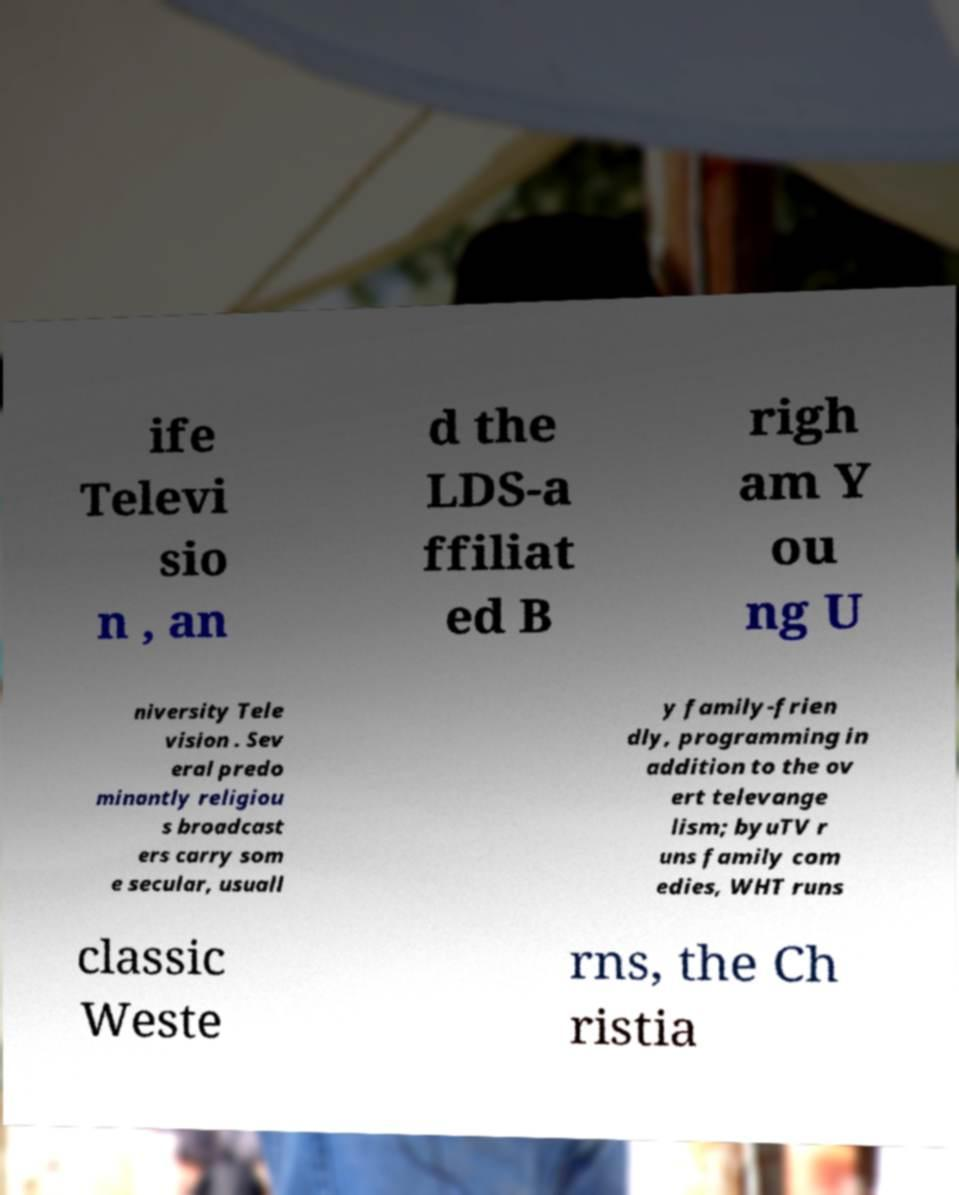I need the written content from this picture converted into text. Can you do that? ife Televi sio n , an d the LDS-a ffiliat ed B righ am Y ou ng U niversity Tele vision . Sev eral predo minantly religiou s broadcast ers carry som e secular, usuall y family-frien dly, programming in addition to the ov ert televange lism; byuTV r uns family com edies, WHT runs classic Weste rns, the Ch ristia 